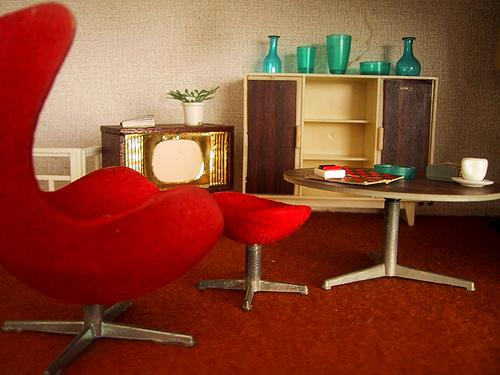This style of furniture was popular in what era?

Choices:
A) 12th century
B) 20th century
C) 19th century
D) 18th century 20th century 